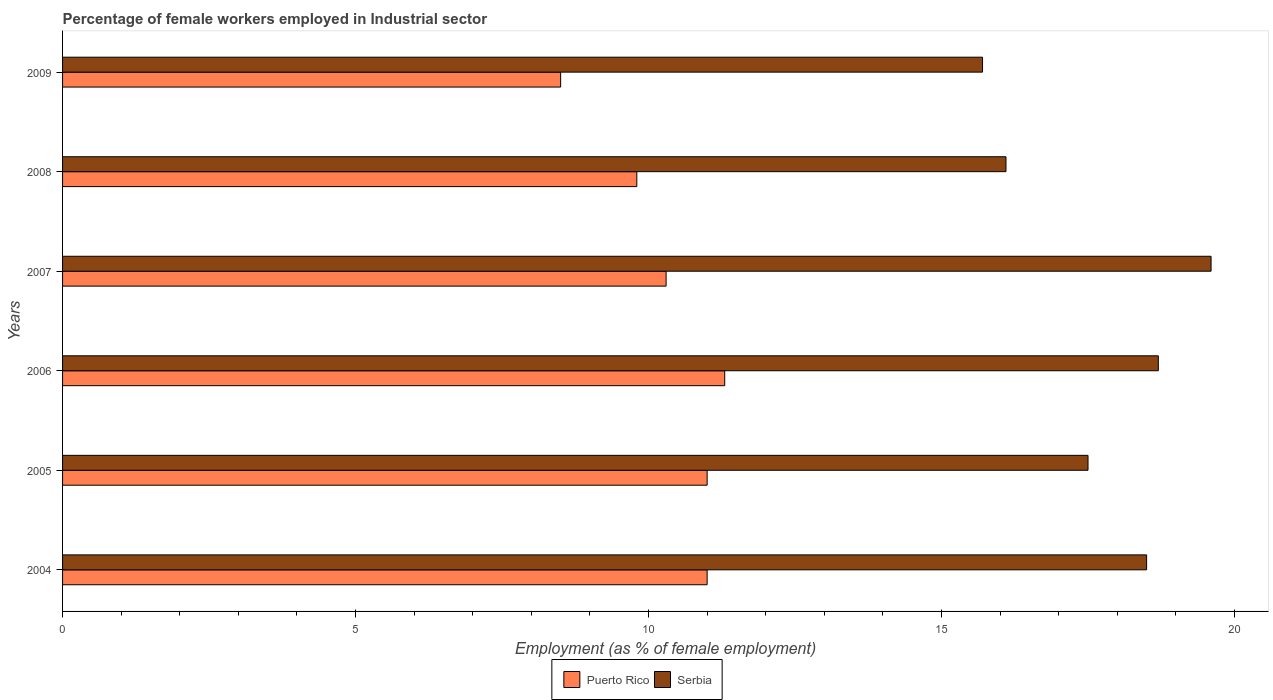How many different coloured bars are there?
Make the answer very short. 2. Are the number of bars per tick equal to the number of legend labels?
Your answer should be compact. Yes. Are the number of bars on each tick of the Y-axis equal?
Your answer should be very brief. Yes. How many bars are there on the 6th tick from the top?
Provide a short and direct response. 2. How many bars are there on the 5th tick from the bottom?
Keep it short and to the point. 2. In how many cases, is the number of bars for a given year not equal to the number of legend labels?
Offer a very short reply. 0. What is the percentage of females employed in Industrial sector in Serbia in 2007?
Ensure brevity in your answer.  19.6. Across all years, what is the maximum percentage of females employed in Industrial sector in Puerto Rico?
Your answer should be very brief. 11.3. Across all years, what is the minimum percentage of females employed in Industrial sector in Serbia?
Ensure brevity in your answer.  15.7. In which year was the percentage of females employed in Industrial sector in Serbia maximum?
Your answer should be very brief. 2007. What is the total percentage of females employed in Industrial sector in Serbia in the graph?
Provide a succinct answer. 106.1. What is the difference between the percentage of females employed in Industrial sector in Puerto Rico in 2008 and that in 2009?
Offer a terse response. 1.3. What is the difference between the percentage of females employed in Industrial sector in Puerto Rico in 2006 and the percentage of females employed in Industrial sector in Serbia in 2008?
Offer a very short reply. -4.8. What is the average percentage of females employed in Industrial sector in Serbia per year?
Make the answer very short. 17.68. What is the ratio of the percentage of females employed in Industrial sector in Puerto Rico in 2005 to that in 2006?
Give a very brief answer. 0.97. Is the percentage of females employed in Industrial sector in Serbia in 2007 less than that in 2008?
Give a very brief answer. No. Is the difference between the percentage of females employed in Industrial sector in Puerto Rico in 2004 and 2009 greater than the difference between the percentage of females employed in Industrial sector in Serbia in 2004 and 2009?
Your answer should be compact. No. What is the difference between the highest and the second highest percentage of females employed in Industrial sector in Puerto Rico?
Give a very brief answer. 0.3. What is the difference between the highest and the lowest percentage of females employed in Industrial sector in Serbia?
Your response must be concise. 3.9. In how many years, is the percentage of females employed in Industrial sector in Puerto Rico greater than the average percentage of females employed in Industrial sector in Puerto Rico taken over all years?
Provide a short and direct response. 3. What does the 2nd bar from the top in 2004 represents?
Your answer should be very brief. Puerto Rico. What does the 1st bar from the bottom in 2006 represents?
Provide a succinct answer. Puerto Rico. How many bars are there?
Give a very brief answer. 12. Are all the bars in the graph horizontal?
Offer a very short reply. Yes. Are the values on the major ticks of X-axis written in scientific E-notation?
Your answer should be very brief. No. Where does the legend appear in the graph?
Your response must be concise. Bottom center. What is the title of the graph?
Your response must be concise. Percentage of female workers employed in Industrial sector. Does "Gambia, The" appear as one of the legend labels in the graph?
Offer a terse response. No. What is the label or title of the X-axis?
Offer a terse response. Employment (as % of female employment). What is the Employment (as % of female employment) in Puerto Rico in 2004?
Make the answer very short. 11. What is the Employment (as % of female employment) of Puerto Rico in 2005?
Give a very brief answer. 11. What is the Employment (as % of female employment) in Serbia in 2005?
Offer a terse response. 17.5. What is the Employment (as % of female employment) in Puerto Rico in 2006?
Give a very brief answer. 11.3. What is the Employment (as % of female employment) of Serbia in 2006?
Make the answer very short. 18.7. What is the Employment (as % of female employment) in Puerto Rico in 2007?
Provide a short and direct response. 10.3. What is the Employment (as % of female employment) in Serbia in 2007?
Offer a very short reply. 19.6. What is the Employment (as % of female employment) in Puerto Rico in 2008?
Give a very brief answer. 9.8. What is the Employment (as % of female employment) of Serbia in 2008?
Your answer should be very brief. 16.1. What is the Employment (as % of female employment) of Puerto Rico in 2009?
Your answer should be very brief. 8.5. What is the Employment (as % of female employment) of Serbia in 2009?
Keep it short and to the point. 15.7. Across all years, what is the maximum Employment (as % of female employment) in Puerto Rico?
Your answer should be very brief. 11.3. Across all years, what is the maximum Employment (as % of female employment) of Serbia?
Make the answer very short. 19.6. Across all years, what is the minimum Employment (as % of female employment) in Puerto Rico?
Your response must be concise. 8.5. Across all years, what is the minimum Employment (as % of female employment) in Serbia?
Your response must be concise. 15.7. What is the total Employment (as % of female employment) of Puerto Rico in the graph?
Offer a very short reply. 61.9. What is the total Employment (as % of female employment) of Serbia in the graph?
Offer a very short reply. 106.1. What is the difference between the Employment (as % of female employment) of Puerto Rico in 2004 and that in 2006?
Offer a terse response. -0.3. What is the difference between the Employment (as % of female employment) of Serbia in 2004 and that in 2006?
Give a very brief answer. -0.2. What is the difference between the Employment (as % of female employment) in Serbia in 2004 and that in 2009?
Make the answer very short. 2.8. What is the difference between the Employment (as % of female employment) in Puerto Rico in 2005 and that in 2006?
Give a very brief answer. -0.3. What is the difference between the Employment (as % of female employment) of Puerto Rico in 2005 and that in 2007?
Offer a terse response. 0.7. What is the difference between the Employment (as % of female employment) of Serbia in 2005 and that in 2007?
Make the answer very short. -2.1. What is the difference between the Employment (as % of female employment) in Serbia in 2005 and that in 2008?
Keep it short and to the point. 1.4. What is the difference between the Employment (as % of female employment) of Puerto Rico in 2005 and that in 2009?
Your answer should be compact. 2.5. What is the difference between the Employment (as % of female employment) in Serbia in 2005 and that in 2009?
Provide a short and direct response. 1.8. What is the difference between the Employment (as % of female employment) of Puerto Rico in 2006 and that in 2007?
Your response must be concise. 1. What is the difference between the Employment (as % of female employment) of Serbia in 2006 and that in 2007?
Your answer should be very brief. -0.9. What is the difference between the Employment (as % of female employment) in Serbia in 2006 and that in 2008?
Offer a very short reply. 2.6. What is the difference between the Employment (as % of female employment) of Puerto Rico in 2006 and that in 2009?
Ensure brevity in your answer.  2.8. What is the difference between the Employment (as % of female employment) in Serbia in 2007 and that in 2008?
Keep it short and to the point. 3.5. What is the difference between the Employment (as % of female employment) of Puerto Rico in 2007 and that in 2009?
Offer a terse response. 1.8. What is the difference between the Employment (as % of female employment) in Serbia in 2007 and that in 2009?
Make the answer very short. 3.9. What is the difference between the Employment (as % of female employment) of Puerto Rico in 2008 and that in 2009?
Provide a short and direct response. 1.3. What is the difference between the Employment (as % of female employment) of Puerto Rico in 2004 and the Employment (as % of female employment) of Serbia in 2007?
Provide a succinct answer. -8.6. What is the difference between the Employment (as % of female employment) in Puerto Rico in 2005 and the Employment (as % of female employment) in Serbia in 2007?
Give a very brief answer. -8.6. What is the difference between the Employment (as % of female employment) in Puerto Rico in 2005 and the Employment (as % of female employment) in Serbia in 2008?
Provide a short and direct response. -5.1. What is the difference between the Employment (as % of female employment) in Puerto Rico in 2006 and the Employment (as % of female employment) in Serbia in 2008?
Your answer should be compact. -4.8. What is the difference between the Employment (as % of female employment) of Puerto Rico in 2007 and the Employment (as % of female employment) of Serbia in 2008?
Your response must be concise. -5.8. What is the average Employment (as % of female employment) in Puerto Rico per year?
Offer a very short reply. 10.32. What is the average Employment (as % of female employment) in Serbia per year?
Keep it short and to the point. 17.68. In the year 2007, what is the difference between the Employment (as % of female employment) in Puerto Rico and Employment (as % of female employment) in Serbia?
Offer a very short reply. -9.3. In the year 2009, what is the difference between the Employment (as % of female employment) in Puerto Rico and Employment (as % of female employment) in Serbia?
Provide a succinct answer. -7.2. What is the ratio of the Employment (as % of female employment) of Puerto Rico in 2004 to that in 2005?
Provide a succinct answer. 1. What is the ratio of the Employment (as % of female employment) in Serbia in 2004 to that in 2005?
Give a very brief answer. 1.06. What is the ratio of the Employment (as % of female employment) in Puerto Rico in 2004 to that in 2006?
Offer a terse response. 0.97. What is the ratio of the Employment (as % of female employment) of Serbia in 2004 to that in 2006?
Give a very brief answer. 0.99. What is the ratio of the Employment (as % of female employment) of Puerto Rico in 2004 to that in 2007?
Your answer should be compact. 1.07. What is the ratio of the Employment (as % of female employment) of Serbia in 2004 to that in 2007?
Provide a succinct answer. 0.94. What is the ratio of the Employment (as % of female employment) of Puerto Rico in 2004 to that in 2008?
Your answer should be compact. 1.12. What is the ratio of the Employment (as % of female employment) of Serbia in 2004 to that in 2008?
Make the answer very short. 1.15. What is the ratio of the Employment (as % of female employment) in Puerto Rico in 2004 to that in 2009?
Provide a short and direct response. 1.29. What is the ratio of the Employment (as % of female employment) of Serbia in 2004 to that in 2009?
Offer a terse response. 1.18. What is the ratio of the Employment (as % of female employment) of Puerto Rico in 2005 to that in 2006?
Your response must be concise. 0.97. What is the ratio of the Employment (as % of female employment) in Serbia in 2005 to that in 2006?
Your response must be concise. 0.94. What is the ratio of the Employment (as % of female employment) of Puerto Rico in 2005 to that in 2007?
Make the answer very short. 1.07. What is the ratio of the Employment (as % of female employment) of Serbia in 2005 to that in 2007?
Provide a short and direct response. 0.89. What is the ratio of the Employment (as % of female employment) in Puerto Rico in 2005 to that in 2008?
Your answer should be compact. 1.12. What is the ratio of the Employment (as % of female employment) of Serbia in 2005 to that in 2008?
Offer a terse response. 1.09. What is the ratio of the Employment (as % of female employment) of Puerto Rico in 2005 to that in 2009?
Your response must be concise. 1.29. What is the ratio of the Employment (as % of female employment) in Serbia in 2005 to that in 2009?
Ensure brevity in your answer.  1.11. What is the ratio of the Employment (as % of female employment) of Puerto Rico in 2006 to that in 2007?
Provide a short and direct response. 1.1. What is the ratio of the Employment (as % of female employment) in Serbia in 2006 to that in 2007?
Provide a succinct answer. 0.95. What is the ratio of the Employment (as % of female employment) of Puerto Rico in 2006 to that in 2008?
Provide a short and direct response. 1.15. What is the ratio of the Employment (as % of female employment) in Serbia in 2006 to that in 2008?
Make the answer very short. 1.16. What is the ratio of the Employment (as % of female employment) in Puerto Rico in 2006 to that in 2009?
Offer a terse response. 1.33. What is the ratio of the Employment (as % of female employment) in Serbia in 2006 to that in 2009?
Offer a terse response. 1.19. What is the ratio of the Employment (as % of female employment) of Puerto Rico in 2007 to that in 2008?
Offer a terse response. 1.05. What is the ratio of the Employment (as % of female employment) of Serbia in 2007 to that in 2008?
Provide a succinct answer. 1.22. What is the ratio of the Employment (as % of female employment) in Puerto Rico in 2007 to that in 2009?
Offer a very short reply. 1.21. What is the ratio of the Employment (as % of female employment) in Serbia in 2007 to that in 2009?
Your answer should be very brief. 1.25. What is the ratio of the Employment (as % of female employment) in Puerto Rico in 2008 to that in 2009?
Give a very brief answer. 1.15. What is the ratio of the Employment (as % of female employment) in Serbia in 2008 to that in 2009?
Ensure brevity in your answer.  1.03. What is the difference between the highest and the second highest Employment (as % of female employment) of Puerto Rico?
Your answer should be very brief. 0.3. What is the difference between the highest and the second highest Employment (as % of female employment) of Serbia?
Provide a short and direct response. 0.9. 